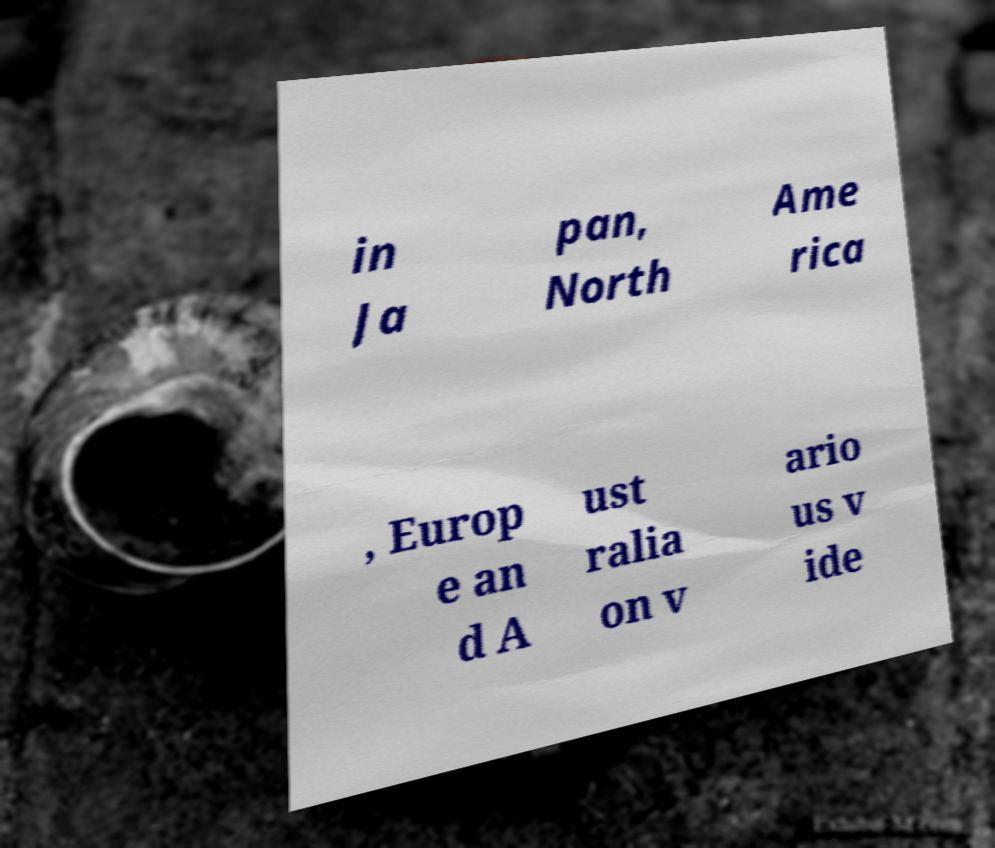Could you extract and type out the text from this image? in Ja pan, North Ame rica , Europ e an d A ust ralia on v ario us v ide 